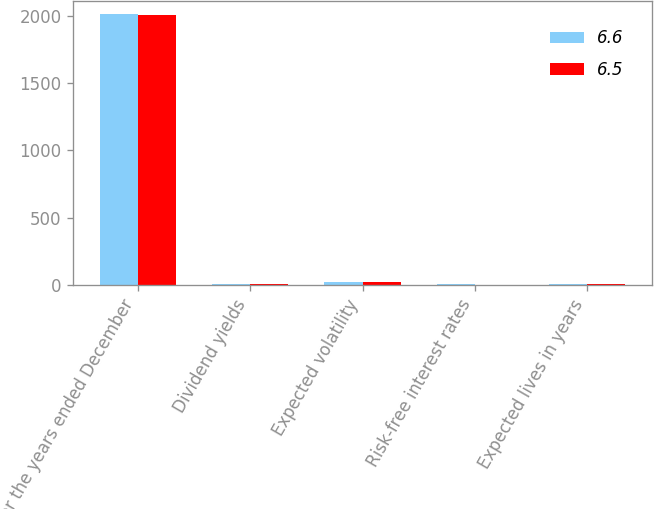Convert chart. <chart><loc_0><loc_0><loc_500><loc_500><stacked_bar_chart><ecel><fcel>For the years ended December<fcel>Dividend yields<fcel>Expected volatility<fcel>Risk-free interest rates<fcel>Expected lives in years<nl><fcel>6.6<fcel>2010<fcel>3.2<fcel>21.7<fcel>3.1<fcel>6.5<nl><fcel>6.5<fcel>2009<fcel>3.3<fcel>21.6<fcel>2.1<fcel>6.6<nl></chart> 